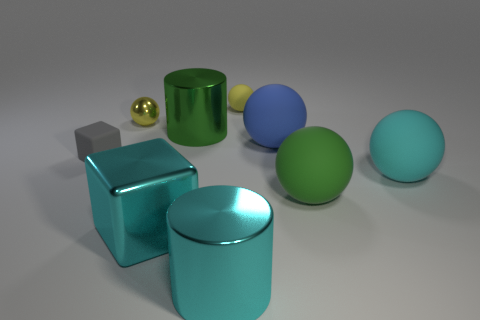There is a tiny rubber thing that is on the left side of the small matte thing to the right of the big cyan cylinder; are there any rubber objects in front of it?
Your answer should be very brief. Yes. Is the color of the tiny metal thing the same as the tiny rubber sphere?
Provide a succinct answer. Yes. There is a sphere that is to the left of the small sphere that is behind the yellow shiny sphere; what color is it?
Offer a terse response. Yellow. What number of big objects are either balls or rubber cubes?
Your response must be concise. 3. There is a rubber thing that is to the left of the blue matte ball and on the right side of the tiny matte cube; what color is it?
Your answer should be compact. Yellow. Is the tiny gray block made of the same material as the blue thing?
Keep it short and to the point. Yes. There is a gray object; what shape is it?
Keep it short and to the point. Cube. What number of large spheres are left of the yellow matte thing that is on the right side of the block that is in front of the large cyan ball?
Keep it short and to the point. 0. There is another small metal thing that is the same shape as the blue object; what is its color?
Provide a succinct answer. Yellow. There is a tiny matte object that is to the right of the rubber object left of the small sphere on the right side of the cyan metal cube; what shape is it?
Offer a very short reply. Sphere. 